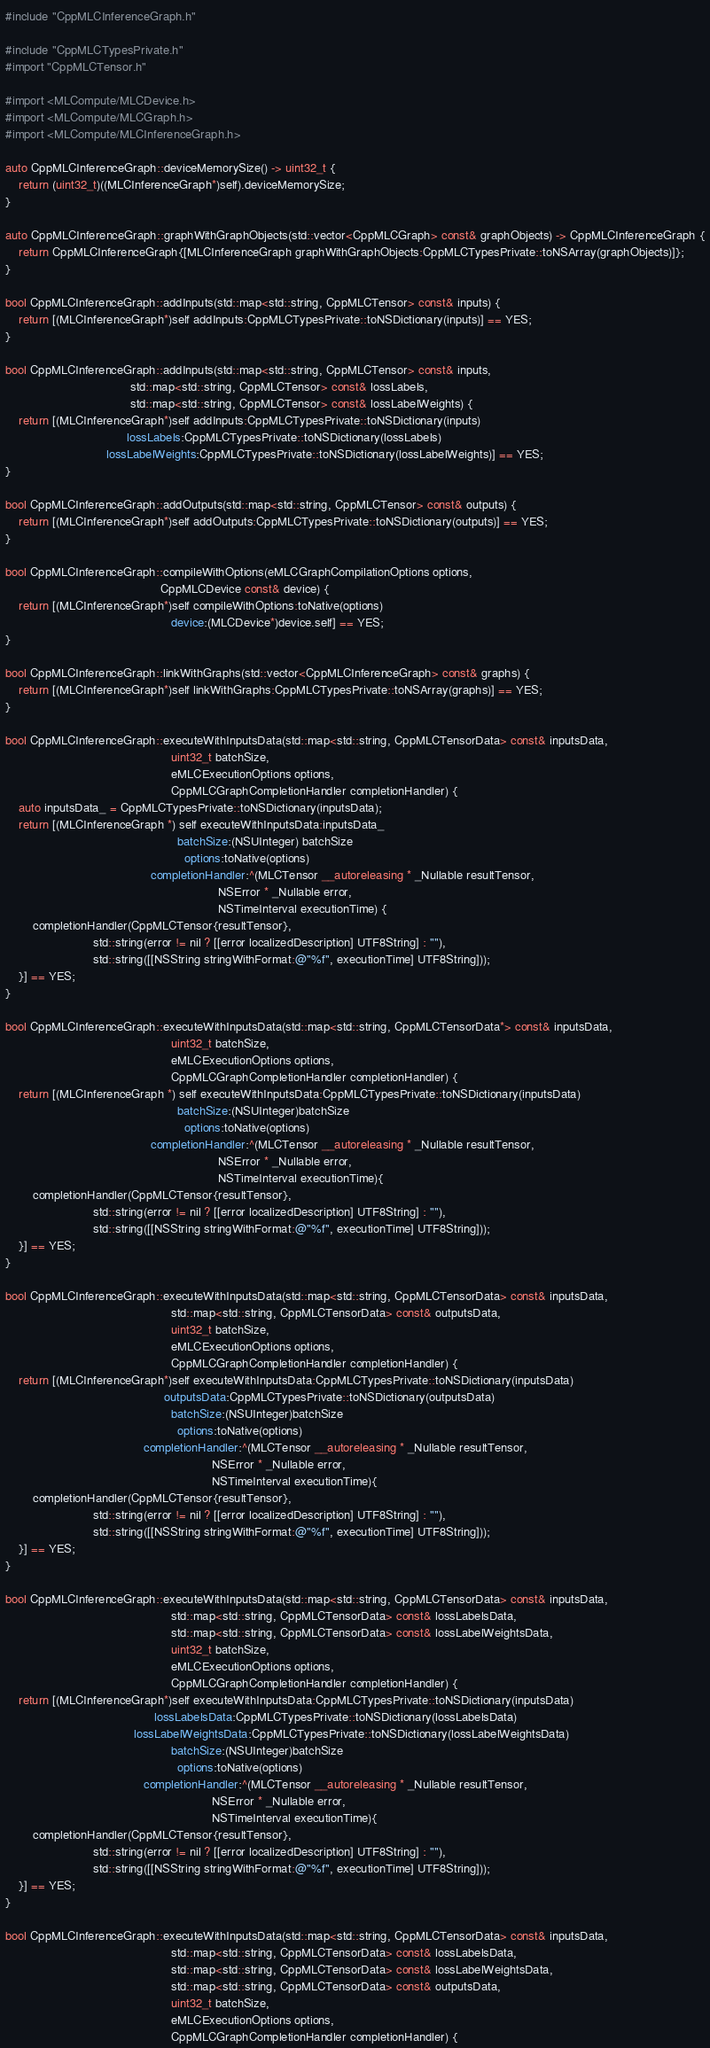Convert code to text. <code><loc_0><loc_0><loc_500><loc_500><_ObjectiveC_>#include "CppMLCInferenceGraph.h"

#include "CppMLCTypesPrivate.h"
#import "CppMLCTensor.h"

#import <MLCompute/MLCDevice.h>
#import <MLCompute/MLCGraph.h>
#import <MLCompute/MLCInferenceGraph.h>

auto CppMLCInferenceGraph::deviceMemorySize() -> uint32_t {
    return (uint32_t)((MLCInferenceGraph*)self).deviceMemorySize;
}

auto CppMLCInferenceGraph::graphWithGraphObjects(std::vector<CppMLCGraph> const& graphObjects) -> CppMLCInferenceGraph {
    return CppMLCInferenceGraph{[MLCInferenceGraph graphWithGraphObjects:CppMLCTypesPrivate::toNSArray(graphObjects)]};
}

bool CppMLCInferenceGraph::addInputs(std::map<std::string, CppMLCTensor> const& inputs) {
    return [(MLCInferenceGraph*)self addInputs:CppMLCTypesPrivate::toNSDictionary(inputs)] == YES;
}

bool CppMLCInferenceGraph::addInputs(std::map<std::string, CppMLCTensor> const& inputs,
                                     std::map<std::string, CppMLCTensor> const& lossLabels,
                                     std::map<std::string, CppMLCTensor> const& lossLabelWeights) {
    return [(MLCInferenceGraph*)self addInputs:CppMLCTypesPrivate::toNSDictionary(inputs)
                                    lossLabels:CppMLCTypesPrivate::toNSDictionary(lossLabels)
                              lossLabelWeights:CppMLCTypesPrivate::toNSDictionary(lossLabelWeights)] == YES;
}

bool CppMLCInferenceGraph::addOutputs(std::map<std::string, CppMLCTensor> const& outputs) {
    return [(MLCInferenceGraph*)self addOutputs:CppMLCTypesPrivate::toNSDictionary(outputs)] == YES;
}

bool CppMLCInferenceGraph::compileWithOptions(eMLCGraphCompilationOptions options,
                                              CppMLCDevice const& device) {
    return [(MLCInferenceGraph*)self compileWithOptions:toNative(options)
                                                 device:(MLCDevice*)device.self] == YES;
}

bool CppMLCInferenceGraph::linkWithGraphs(std::vector<CppMLCInferenceGraph> const& graphs) {
    return [(MLCInferenceGraph*)self linkWithGraphs:CppMLCTypesPrivate::toNSArray(graphs)] == YES;
}

bool CppMLCInferenceGraph::executeWithInputsData(std::map<std::string, CppMLCTensorData> const& inputsData,
                                                 uint32_t batchSize,
                                                 eMLCExecutionOptions options,
                                                 CppMLCGraphCompletionHandler completionHandler) {
    auto inputsData_ = CppMLCTypesPrivate::toNSDictionary(inputsData);
    return [(MLCInferenceGraph *) self executeWithInputsData:inputsData_
                                                   batchSize:(NSUInteger) batchSize
                                                     options:toNative(options)
                                           completionHandler:^(MLCTensor __autoreleasing * _Nullable resultTensor,
                                                               NSError * _Nullable error,
                                                               NSTimeInterval executionTime) {
        completionHandler(CppMLCTensor{resultTensor},
                          std::string(error != nil ? [[error localizedDescription] UTF8String] : ""),
                          std::string([[NSString stringWithFormat:@"%f", executionTime] UTF8String]));
    }] == YES;
}

bool CppMLCInferenceGraph::executeWithInputsData(std::map<std::string, CppMLCTensorData*> const& inputsData,
                                                 uint32_t batchSize,
                                                 eMLCExecutionOptions options,
                                                 CppMLCGraphCompletionHandler completionHandler) {
    return [(MLCInferenceGraph *) self executeWithInputsData:CppMLCTypesPrivate::toNSDictionary(inputsData)
                                                   batchSize:(NSUInteger)batchSize
                                                     options:toNative(options)
                                           completionHandler:^(MLCTensor __autoreleasing * _Nullable resultTensor,
                                                               NSError * _Nullable error,
                                                               NSTimeInterval executionTime){
        completionHandler(CppMLCTensor{resultTensor},
                          std::string(error != nil ? [[error localizedDescription] UTF8String] : ""),
                          std::string([[NSString stringWithFormat:@"%f", executionTime] UTF8String]));
    }] == YES;
}

bool CppMLCInferenceGraph::executeWithInputsData(std::map<std::string, CppMLCTensorData> const& inputsData,
                                                 std::map<std::string, CppMLCTensorData> const& outputsData,
                                                 uint32_t batchSize,
                                                 eMLCExecutionOptions options,
                                                 CppMLCGraphCompletionHandler completionHandler) {
    return [(MLCInferenceGraph*)self executeWithInputsData:CppMLCTypesPrivate::toNSDictionary(inputsData)
                                               outputsData:CppMLCTypesPrivate::toNSDictionary(outputsData)
                                                 batchSize:(NSUInteger)batchSize
                                                   options:toNative(options)
                                         completionHandler:^(MLCTensor __autoreleasing * _Nullable resultTensor,
                                                             NSError * _Nullable error,
                                                             NSTimeInterval executionTime){
        completionHandler(CppMLCTensor{resultTensor},
                          std::string(error != nil ? [[error localizedDescription] UTF8String] : ""),
                          std::string([[NSString stringWithFormat:@"%f", executionTime] UTF8String]));
    }] == YES;
}

bool CppMLCInferenceGraph::executeWithInputsData(std::map<std::string, CppMLCTensorData> const& inputsData,
                                                 std::map<std::string, CppMLCTensorData> const& lossLabelsData,
                                                 std::map<std::string, CppMLCTensorData> const& lossLabelWeightsData,
                                                 uint32_t batchSize,
                                                 eMLCExecutionOptions options,
                                                 CppMLCGraphCompletionHandler completionHandler) {
    return [(MLCInferenceGraph*)self executeWithInputsData:CppMLCTypesPrivate::toNSDictionary(inputsData)
                                            lossLabelsData:CppMLCTypesPrivate::toNSDictionary(lossLabelsData)
                                      lossLabelWeightsData:CppMLCTypesPrivate::toNSDictionary(lossLabelWeightsData)
                                                 batchSize:(NSUInteger)batchSize
                                                   options:toNative(options)
                                         completionHandler:^(MLCTensor __autoreleasing * _Nullable resultTensor,
                                                             NSError * _Nullable error,
                                                             NSTimeInterval executionTime){
        completionHandler(CppMLCTensor{resultTensor},
                          std::string(error != nil ? [[error localizedDescription] UTF8String] : ""),
                          std::string([[NSString stringWithFormat:@"%f", executionTime] UTF8String]));
    }] == YES;
}

bool CppMLCInferenceGraph::executeWithInputsData(std::map<std::string, CppMLCTensorData> const& inputsData,
                                                 std::map<std::string, CppMLCTensorData> const& lossLabelsData,
                                                 std::map<std::string, CppMLCTensorData> const& lossLabelWeightsData,
                                                 std::map<std::string, CppMLCTensorData> const& outputsData,
                                                 uint32_t batchSize,
                                                 eMLCExecutionOptions options,
                                                 CppMLCGraphCompletionHandler completionHandler) {</code> 